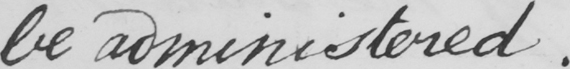What does this handwritten line say? be administered . 